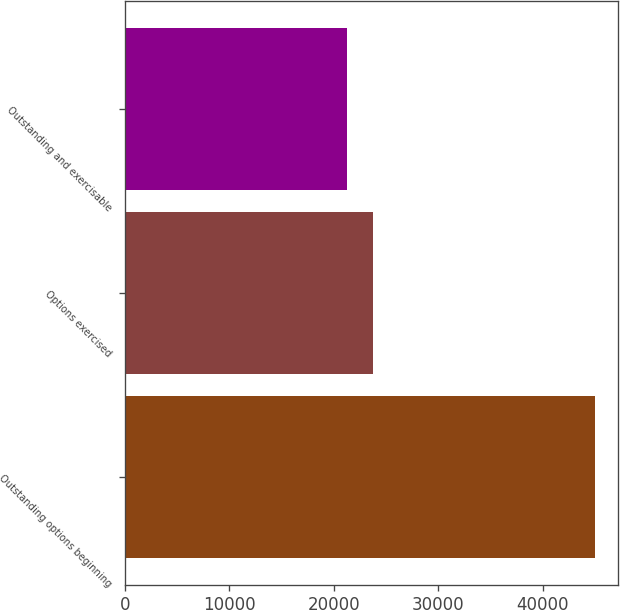<chart> <loc_0><loc_0><loc_500><loc_500><bar_chart><fcel>Outstanding options beginning<fcel>Options exercised<fcel>Outstanding and exercisable<nl><fcel>45007<fcel>23713<fcel>21294<nl></chart> 